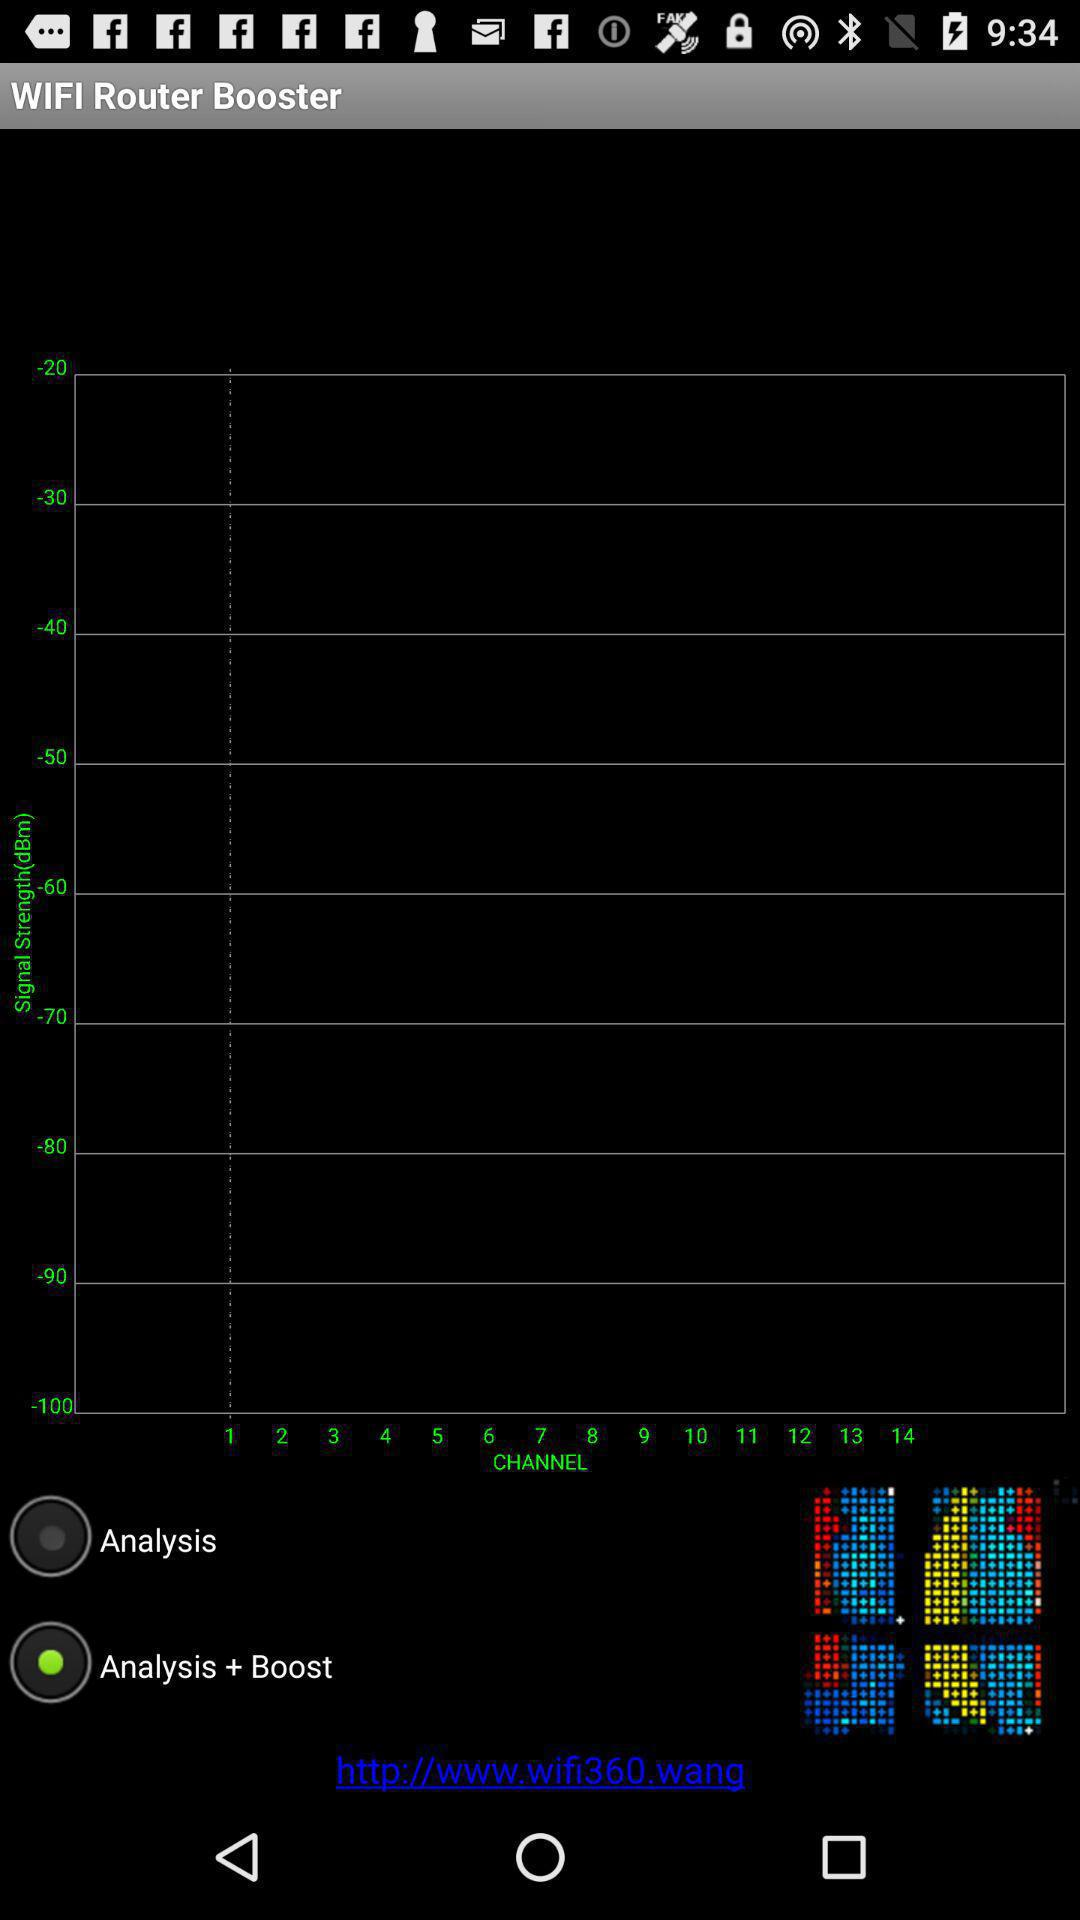What are the two parameters given on the bar graph? The two parameters are channel and signal strength (dBm). 